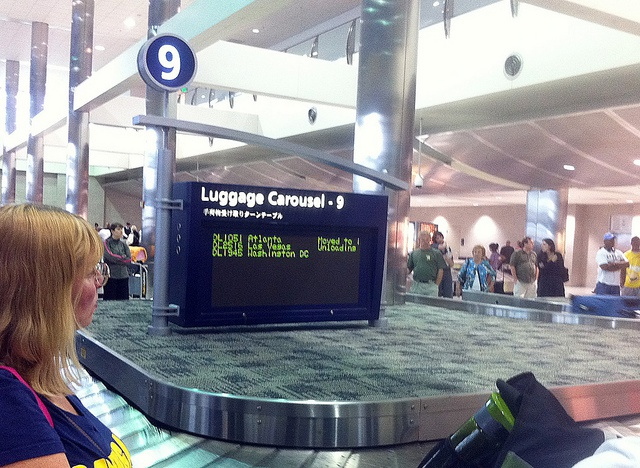Describe the objects in this image and their specific colors. I can see people in lightgray, navy, maroon, gray, and black tones, people in lightgray, black, gray, and darkgray tones, people in lightgray, gray, and purple tones, people in lightgray, lavender, gray, and darkgray tones, and people in lightgray, gray, and darkgray tones in this image. 